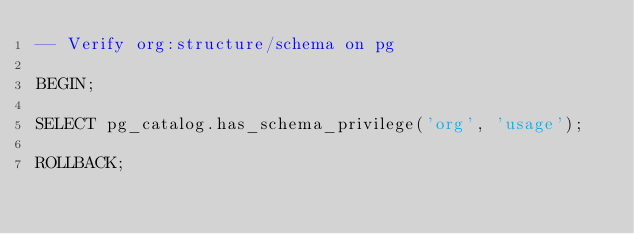Convert code to text. <code><loc_0><loc_0><loc_500><loc_500><_SQL_>-- Verify org:structure/schema on pg

BEGIN;

SELECT pg_catalog.has_schema_privilege('org', 'usage');

ROLLBACK;
</code> 